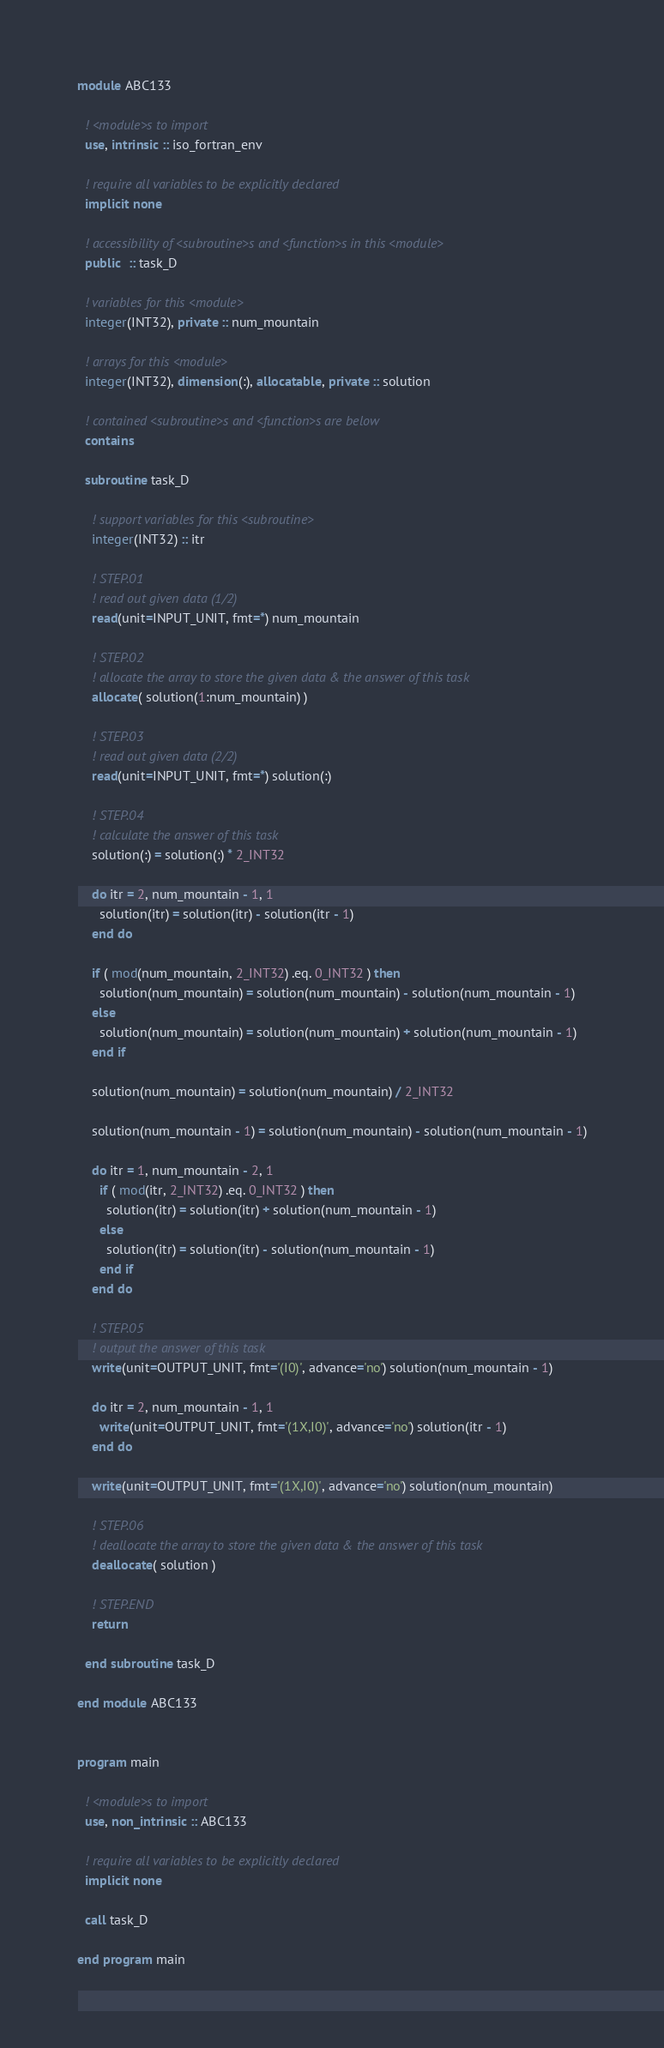<code> <loc_0><loc_0><loc_500><loc_500><_FORTRAN_>module ABC133

  ! <module>s to import
  use, intrinsic :: iso_fortran_env

  ! require all variables to be explicitly declared
  implicit none

  ! accessibility of <subroutine>s and <function>s in this <module>
  public  :: task_D

  ! variables for this <module>
  integer(INT32), private :: num_mountain

  ! arrays for this <module>
  integer(INT32), dimension(:), allocatable, private :: solution

  ! contained <subroutine>s and <function>s are below
  contains

  subroutine task_D

    ! support variables for this <subroutine>
    integer(INT32) :: itr

    ! STEP.01
    ! read out given data (1/2)
    read(unit=INPUT_UNIT, fmt=*) num_mountain

    ! STEP.02
    ! allocate the array to store the given data & the answer of this task
    allocate( solution(1:num_mountain) )

    ! STEP.03
    ! read out given data (2/2)
    read(unit=INPUT_UNIT, fmt=*) solution(:)

    ! STEP.04
    ! calculate the answer of this task
    solution(:) = solution(:) * 2_INT32

    do itr = 2, num_mountain - 1, 1
      solution(itr) = solution(itr) - solution(itr - 1)
    end do

    if ( mod(num_mountain, 2_INT32) .eq. 0_INT32 ) then
      solution(num_mountain) = solution(num_mountain) - solution(num_mountain - 1)
    else
      solution(num_mountain) = solution(num_mountain) + solution(num_mountain - 1)
    end if

    solution(num_mountain) = solution(num_mountain) / 2_INT32

    solution(num_mountain - 1) = solution(num_mountain) - solution(num_mountain - 1)

    do itr = 1, num_mountain - 2, 1
      if ( mod(itr, 2_INT32) .eq. 0_INT32 ) then
        solution(itr) = solution(itr) + solution(num_mountain - 1)
      else
        solution(itr) = solution(itr) - solution(num_mountain - 1)
      end if
    end do

    ! STEP.05
    ! output the answer of this task
    write(unit=OUTPUT_UNIT, fmt='(I0)', advance='no') solution(num_mountain - 1)

    do itr = 2, num_mountain - 1, 1
      write(unit=OUTPUT_UNIT, fmt='(1X,I0)', advance='no') solution(itr - 1)
    end do

    write(unit=OUTPUT_UNIT, fmt='(1X,I0)', advance='no') solution(num_mountain)

    ! STEP.06
    ! deallocate the array to store the given data & the answer of this task
    deallocate( solution )

    ! STEP.END
    return

  end subroutine task_D

end module ABC133


program main

  ! <module>s to import
  use, non_intrinsic :: ABC133

  ! require all variables to be explicitly declared
  implicit none

  call task_D

end program main</code> 